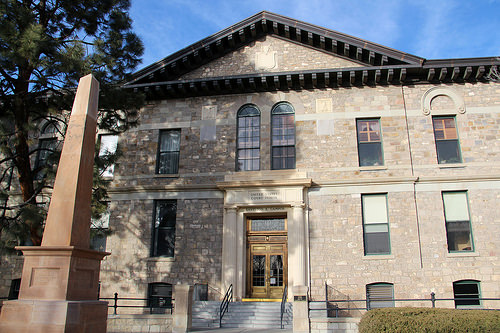<image>
Is the house in front of the tree? No. The house is not in front of the tree. The spatial positioning shows a different relationship between these objects. 